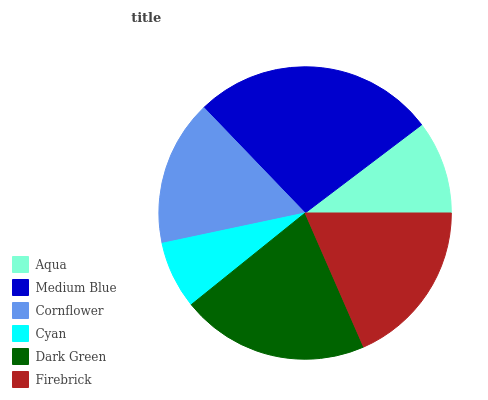Is Cyan the minimum?
Answer yes or no. Yes. Is Medium Blue the maximum?
Answer yes or no. Yes. Is Cornflower the minimum?
Answer yes or no. No. Is Cornflower the maximum?
Answer yes or no. No. Is Medium Blue greater than Cornflower?
Answer yes or no. Yes. Is Cornflower less than Medium Blue?
Answer yes or no. Yes. Is Cornflower greater than Medium Blue?
Answer yes or no. No. Is Medium Blue less than Cornflower?
Answer yes or no. No. Is Firebrick the high median?
Answer yes or no. Yes. Is Cornflower the low median?
Answer yes or no. Yes. Is Cyan the high median?
Answer yes or no. No. Is Firebrick the low median?
Answer yes or no. No. 